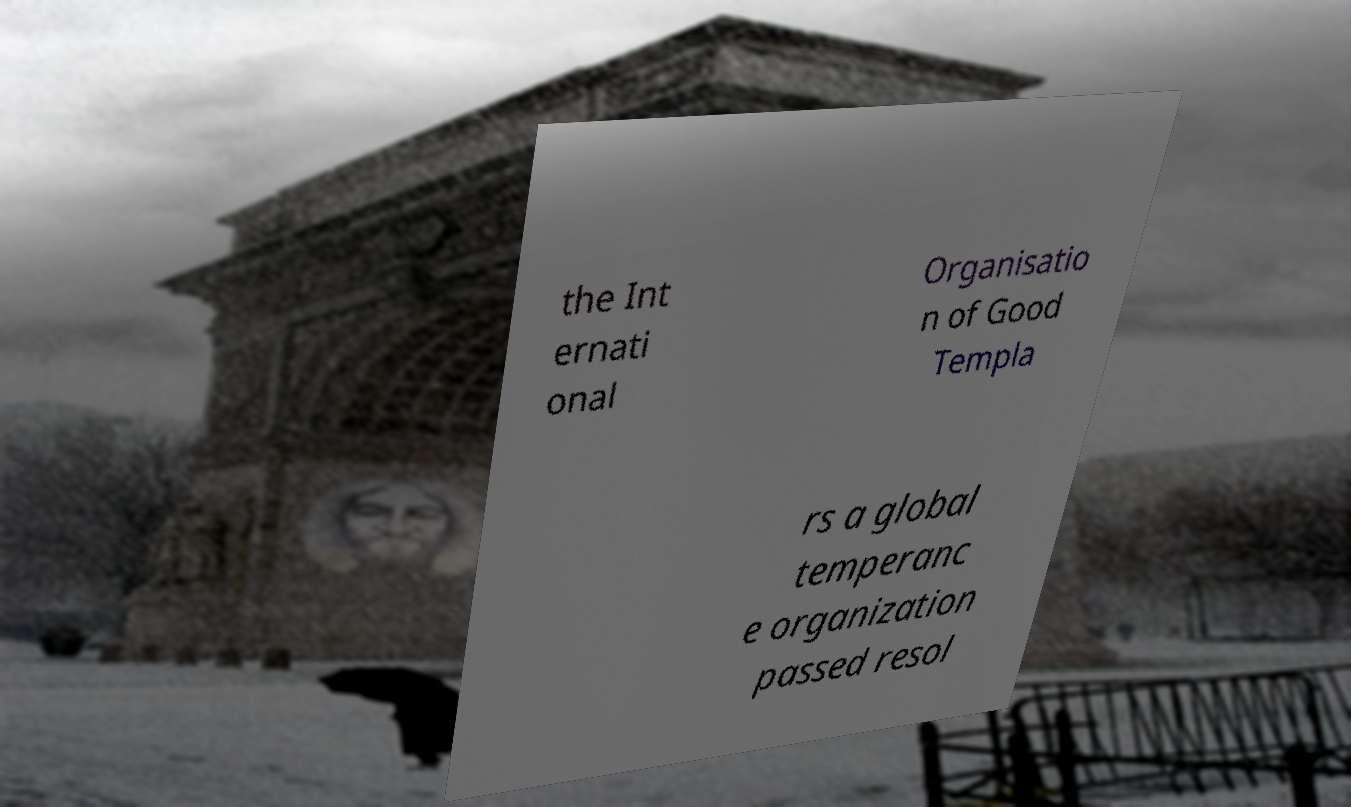Can you read and provide the text displayed in the image?This photo seems to have some interesting text. Can you extract and type it out for me? the Int ernati onal Organisatio n of Good Templa rs a global temperanc e organization passed resol 